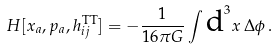Convert formula to latex. <formula><loc_0><loc_0><loc_500><loc_500>H [ { x } _ { a } , { p } _ { a } , h _ { i j } ^ { \text {TT} } ] = - \frac { 1 } { 1 6 \pi G } \int { \text {d} ^ { 3 } x \, \Delta \phi } \, .</formula> 